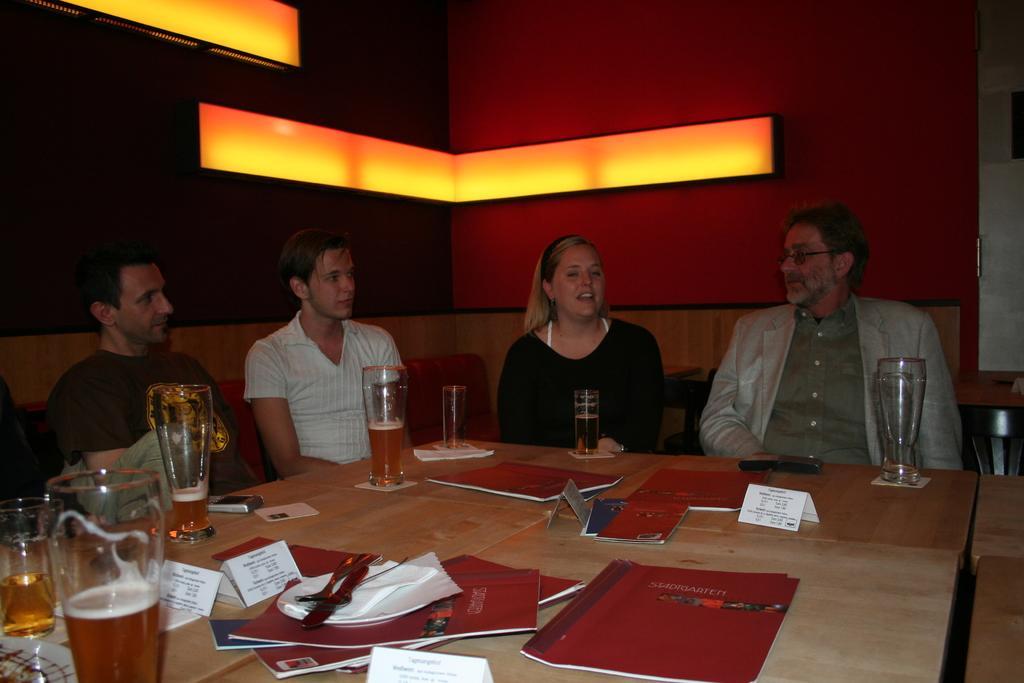In one or two sentences, can you explain what this image depicts? There is a table ,on that table there are some glasses which contains wine and on the table ,there are some books in brown color and some receipts in white color,some peoples sitting on the chairs and in the background there is a wall and a yellow color light. 